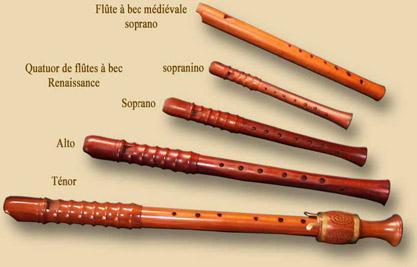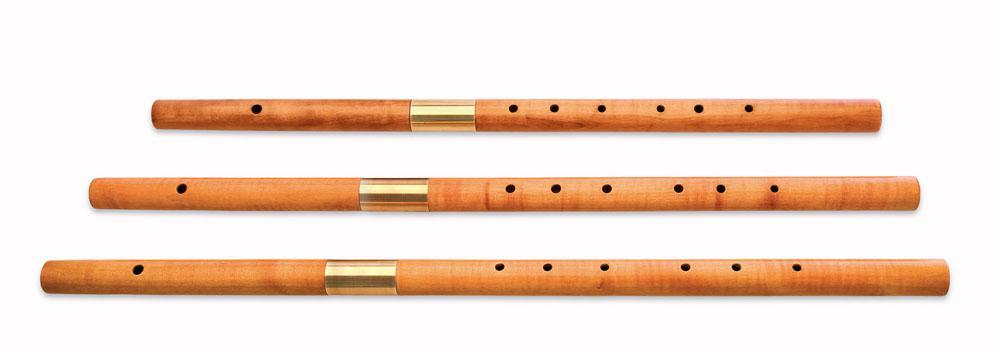The first image is the image on the left, the second image is the image on the right. Examine the images to the left and right. Is the description "The flutes in one of the images are arranged with top to bottom from smallest to largest." accurate? Answer yes or no. Yes. 